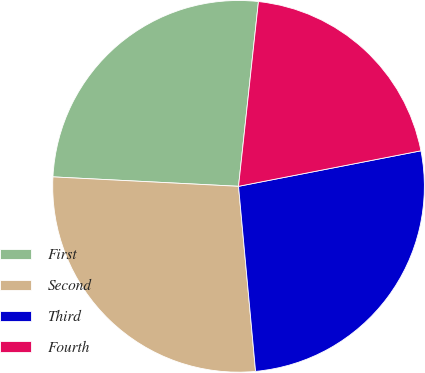<chart> <loc_0><loc_0><loc_500><loc_500><pie_chart><fcel>First<fcel>Second<fcel>Third<fcel>Fourth<nl><fcel>25.9%<fcel>27.27%<fcel>26.6%<fcel>20.23%<nl></chart> 